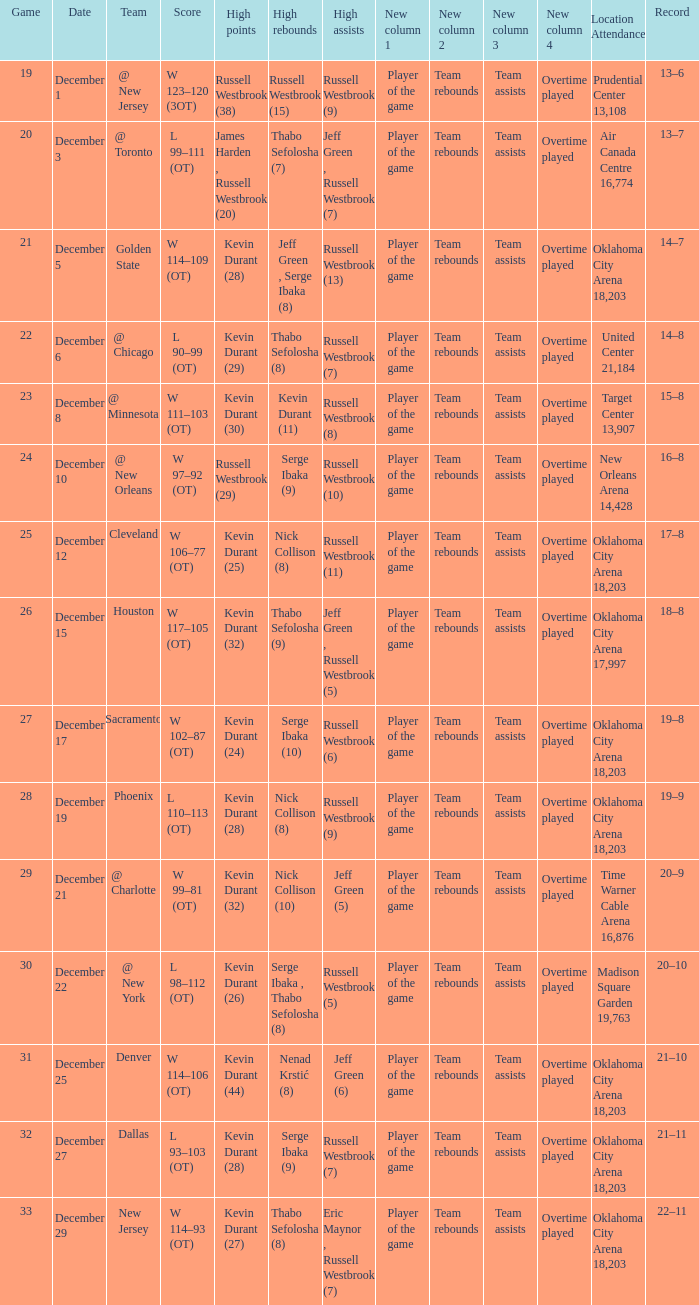What was the record on December 27? 21–11. 